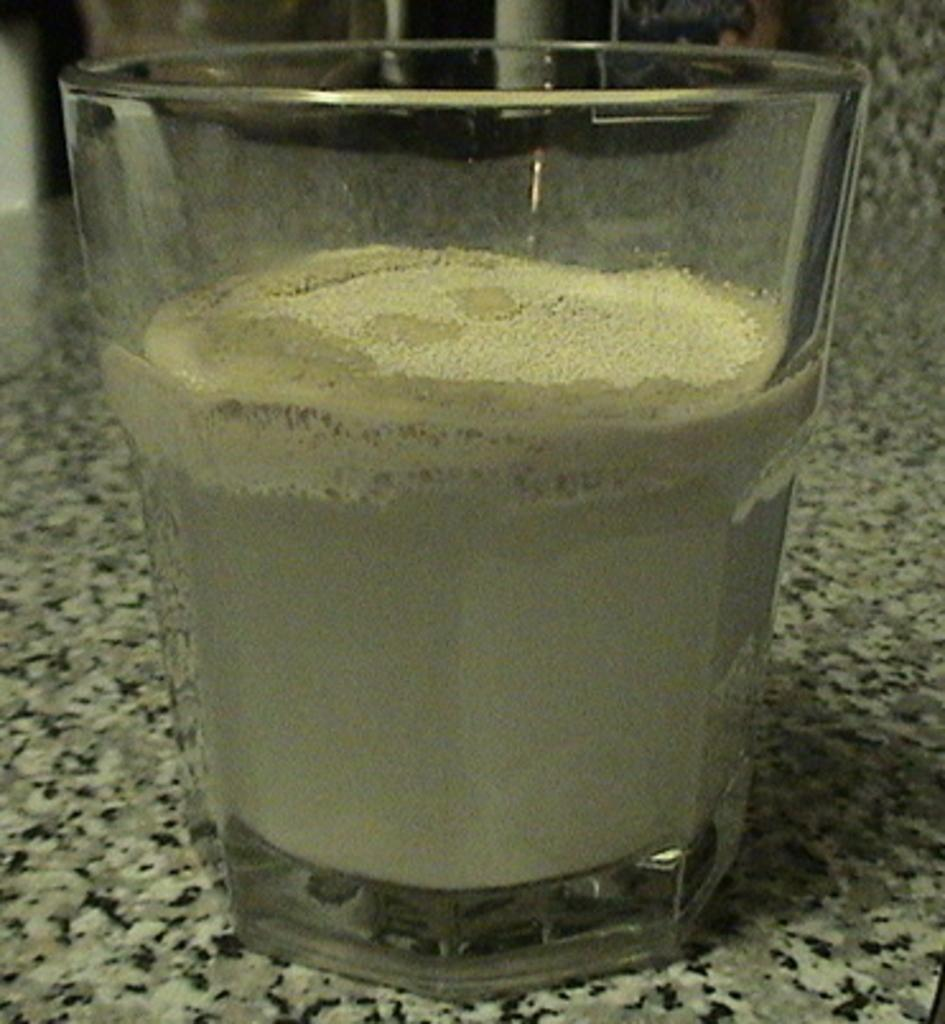What is in the glass that is visible in the image? The glass contains powder in the image. Where is the glass located in the image? The glass is on a platform in the image. How many snails can be seen driving vehicles in the image? There are no snails or vehicles present in the image. 